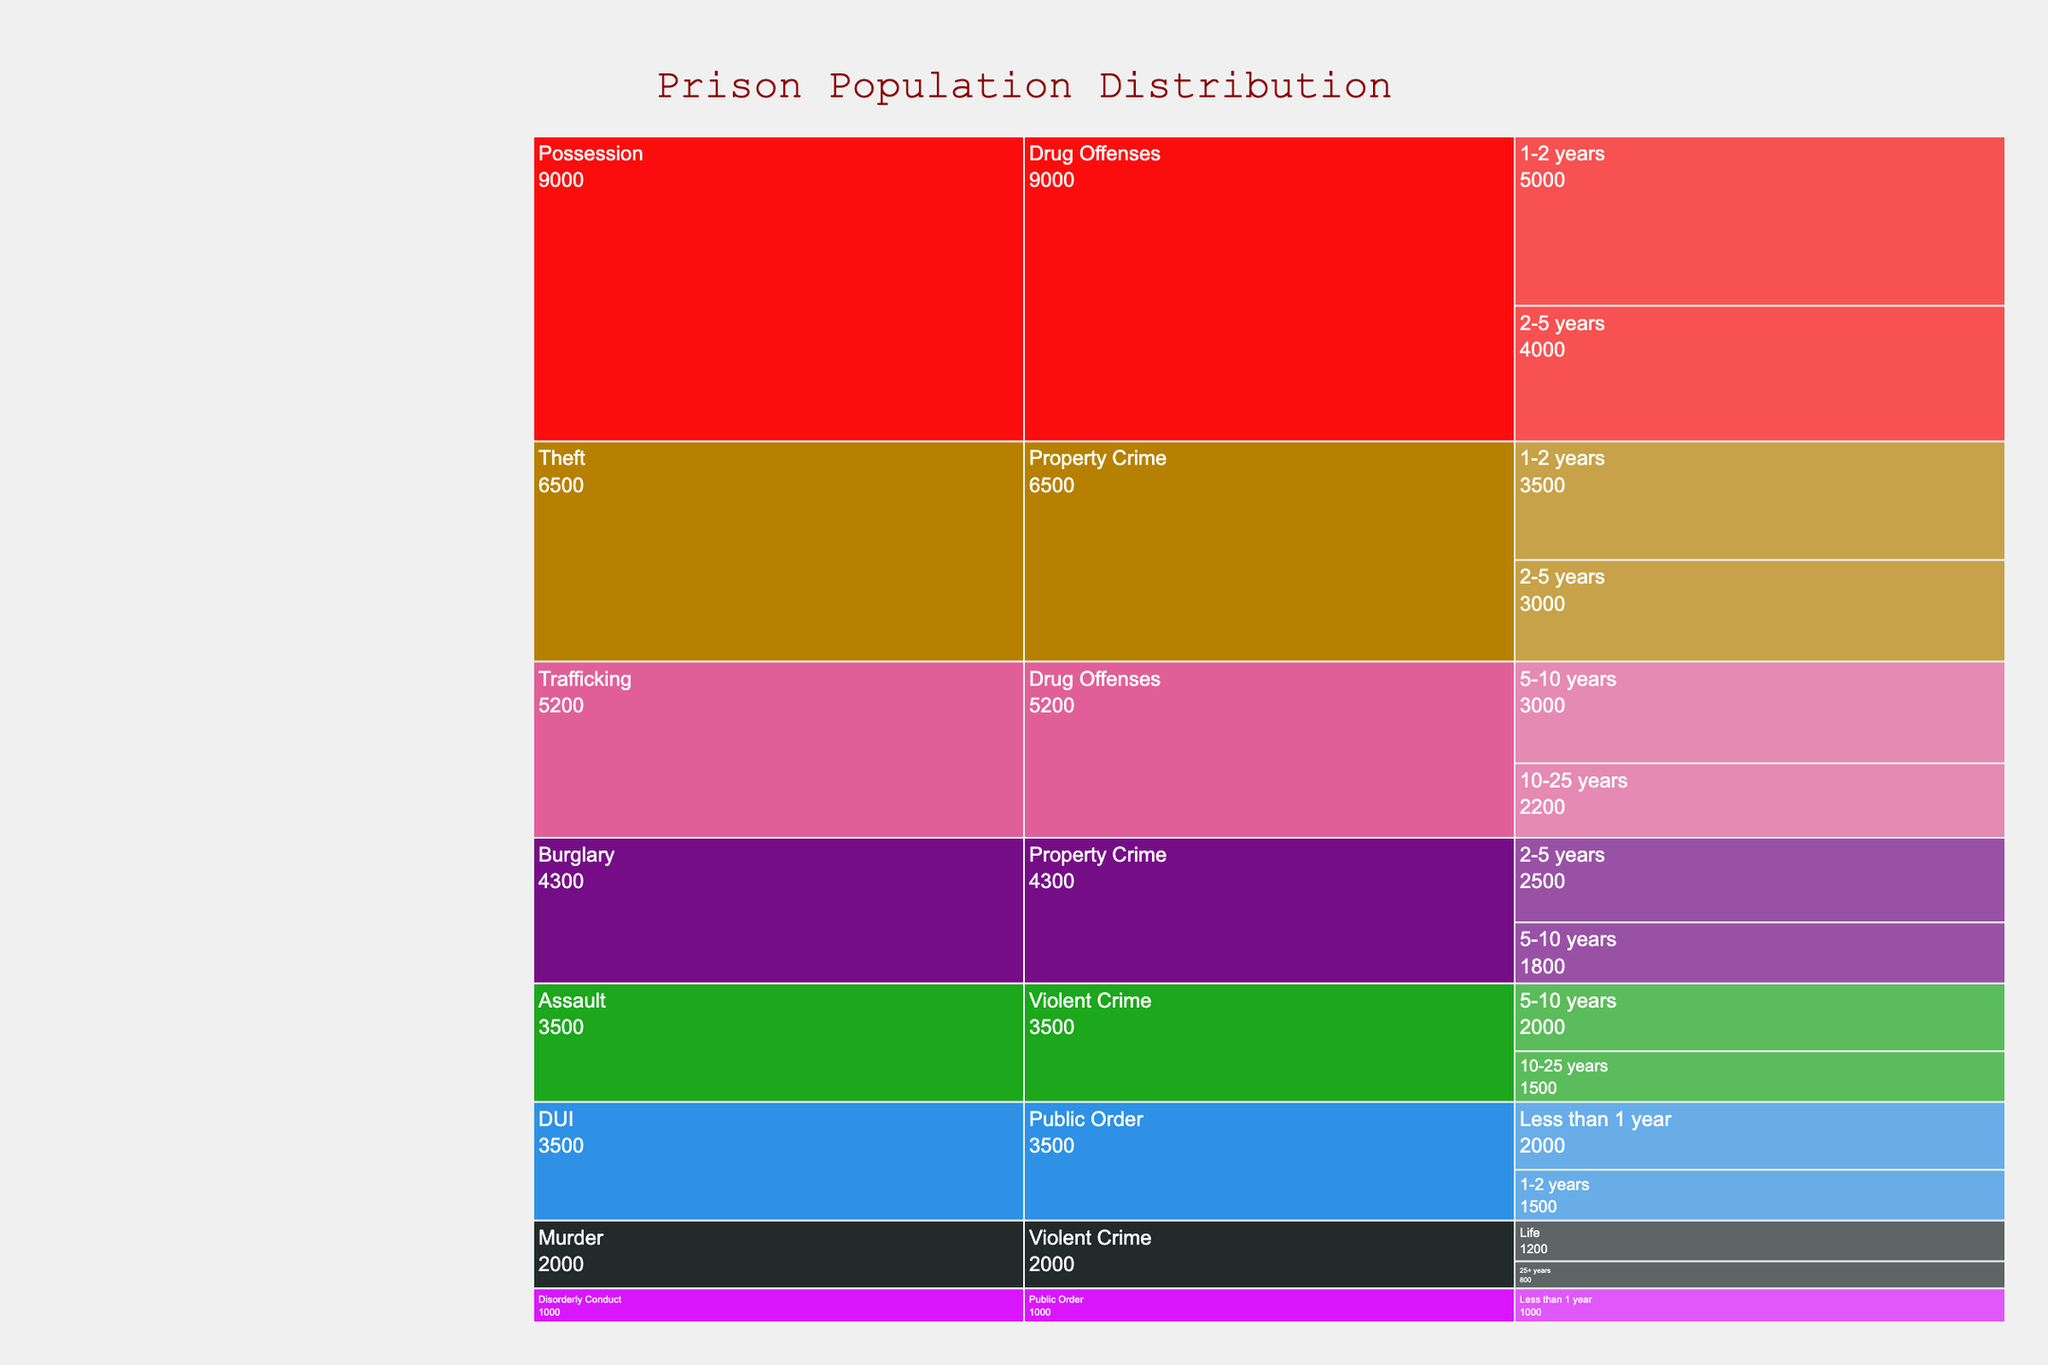Which offense category has the highest prison population? The Icicle Chart shows the categories 'Violent Crime', 'Property Crime', 'Drug Offenses', and 'Public Order'. By summing the values of each, we see that 'Drug Offenses' has the highest total population (2200 + 3000 + 4000 + 5000 = 14200).
Answer: Drug Offenses Which sentence length under 'Property Crime' has the largest population? Within 'Property Crime', we look at the subdivisions: 'Burglary' and 'Theft'. The highest is 'Theft' with a sentence length of 1-2 years and a population of 3500.
Answer: 1-2 years Compare the population numbers for 'Assault' in the 'Violent Crime' category for different sentence lengths. Which has a higher population: 5-10 years or 10-25 years? The populations for 'Assault' with 5-10 years is 2000, and for 10-25 years it is 1500. Therefore, 5-10 years has a higher population.
Answer: 5-10 years What is the difference in population between 'Possession' and 'Trafficking' within 'Drug Offenses'? The populations for 'Possession' (4000 + 5000 = 9000) and 'Trafficking' (2200 + 3000 = 5200). The difference is 9000 - 5200 = 3800.
Answer: 3800 In the 'Public Order' category, which offense type (DUI or Disorderly Conduct) has a higher total population? For 'Public Order', DUI has a population of 1500 (1-2 years) + 2000 (Less than 1 year) = 3500. Disorderly Conduct has 1000 (Less than 1 year). DUI has a higher total population.
Answer: DUI What is the total population of inmates serving less than 1 year across all offense categories? Summing up all populations for under 1 year sentences: Disorderly Conduct (1000) + DUI (2000) = 3000. Thus, the total is 3000.
Answer: 3000 Which category under 'Violent Crime' has the highest population for life sentences? Within 'Violent Crime', 'Murder' is the only category with life sentences, having a population of 1200.
Answer: Murder What is the ratio of prisoners with life sentences versus those with 25+ years in 'Violent Crime'? For 'Violent Crime', life sentences have 1200, and 25+ years have 800. The ratio is 1200/800 = 1.5.
Answer: 1.5 Which offense under 'Property Crime' has more inmates serving 2-5 years? In 'Property Crime', 'Burglary' has 2500 inmates serving 2-5 years, while 'Theft' has 3000 inmates serving 2-5 years. Therefore, 'Theft' has more inmates for this length.
Answer: Theft What is the combined population of inmates serving 10-25 years in all categories? Adding the populations: Assault (1500) + Trafficking (2200) = 3700 for inmates serving 10-25 years across all categories.
Answer: 3700 